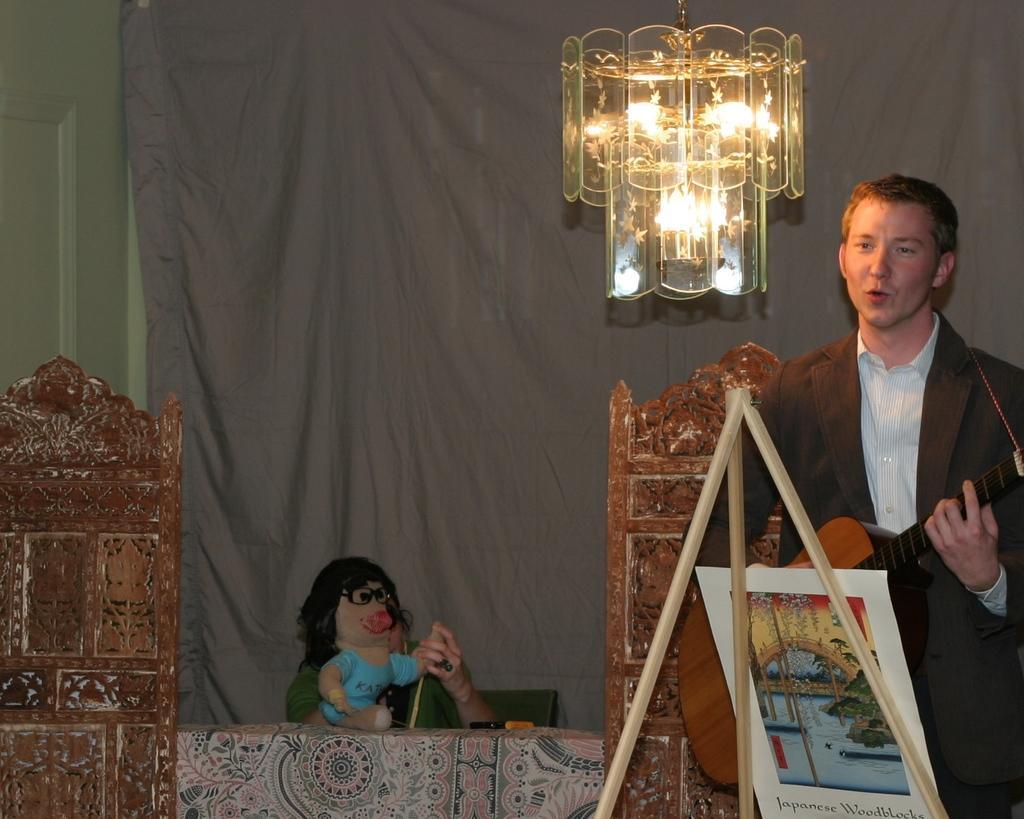How would you summarize this image in a sentence or two? In this image there is a man on the right side who is playing the guitar. In front of him there is a stand on which there is a board. At the top there is a chandelier. In the middle there is a table on which there is a doll. In the background there is a curtain. On the left side there is a door. 